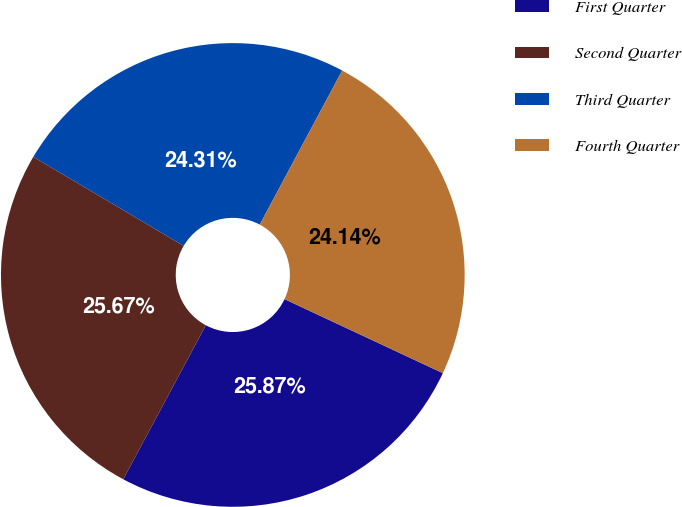Convert chart. <chart><loc_0><loc_0><loc_500><loc_500><pie_chart><fcel>First Quarter<fcel>Second Quarter<fcel>Third Quarter<fcel>Fourth Quarter<nl><fcel>25.87%<fcel>25.67%<fcel>24.31%<fcel>24.14%<nl></chart> 